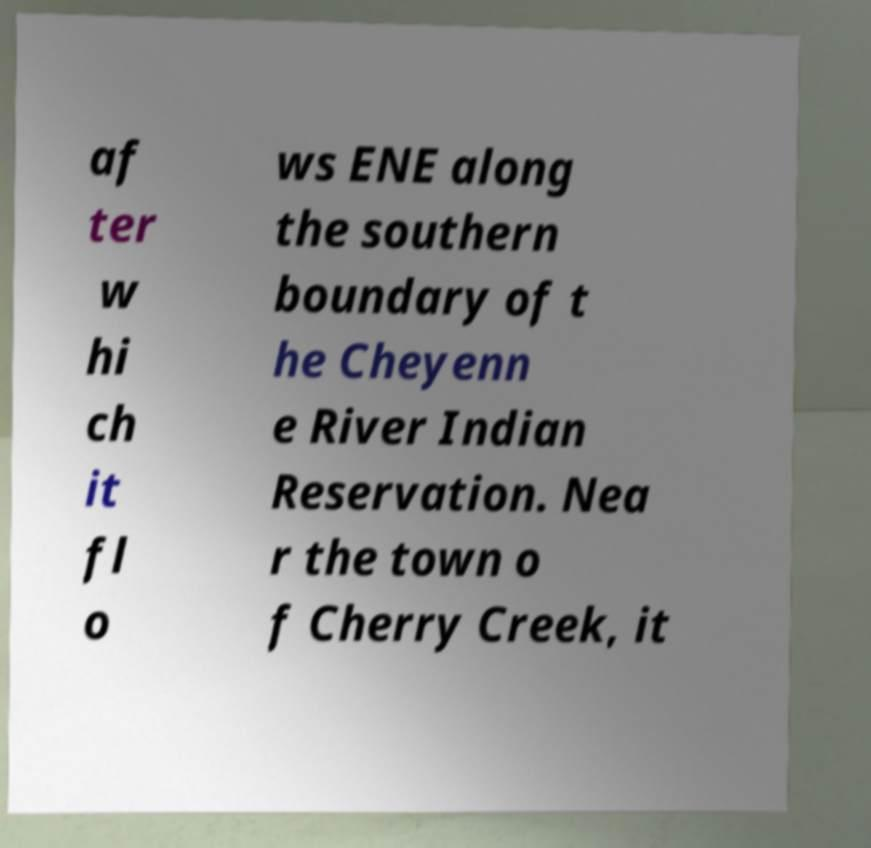Could you extract and type out the text from this image? af ter w hi ch it fl o ws ENE along the southern boundary of t he Cheyenn e River Indian Reservation. Nea r the town o f Cherry Creek, it 